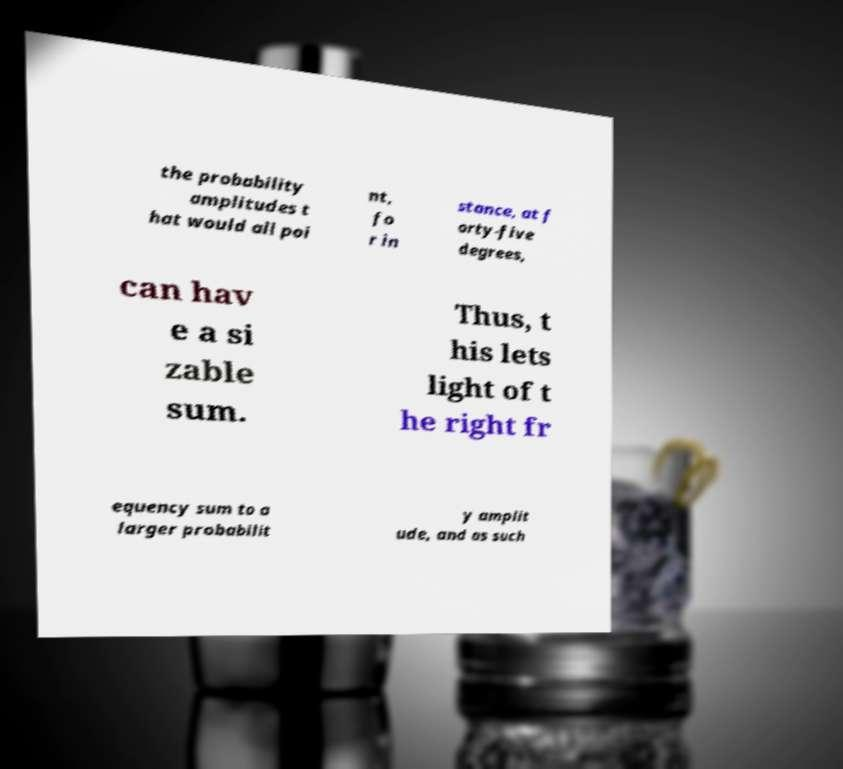There's text embedded in this image that I need extracted. Can you transcribe it verbatim? the probability amplitudes t hat would all poi nt, fo r in stance, at f orty-five degrees, can hav e a si zable sum. Thus, t his lets light of t he right fr equency sum to a larger probabilit y amplit ude, and as such 